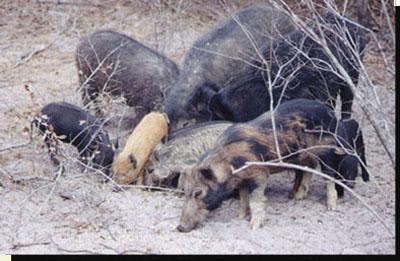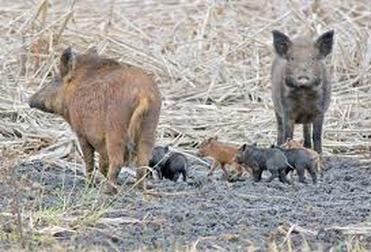The first image is the image on the left, the second image is the image on the right. Analyze the images presented: Is the assertion "At least one of the animals pictured is dead." valid? Answer yes or no. No. 